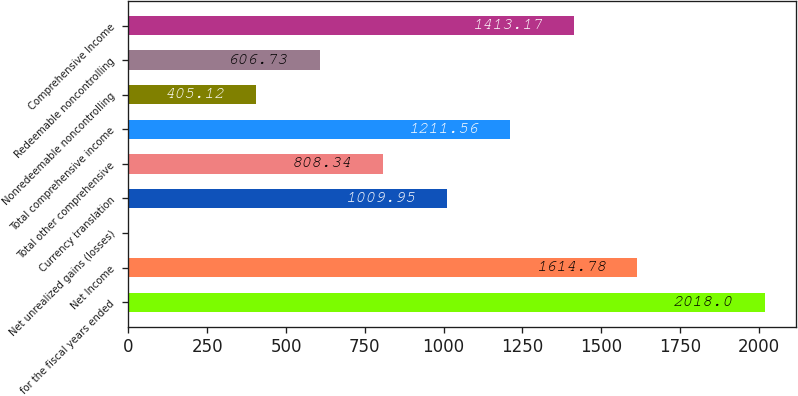Convert chart. <chart><loc_0><loc_0><loc_500><loc_500><bar_chart><fcel>for the fiscal years ended<fcel>Net Income<fcel>Net unrealized gains (losses)<fcel>Currency translation<fcel>Total other comprehensive<fcel>Total comprehensive income<fcel>Nonredeemable noncontrolling<fcel>Redeemable noncontrolling<fcel>Comprehensive Income<nl><fcel>2018<fcel>1614.78<fcel>1.9<fcel>1009.95<fcel>808.34<fcel>1211.56<fcel>405.12<fcel>606.73<fcel>1413.17<nl></chart> 